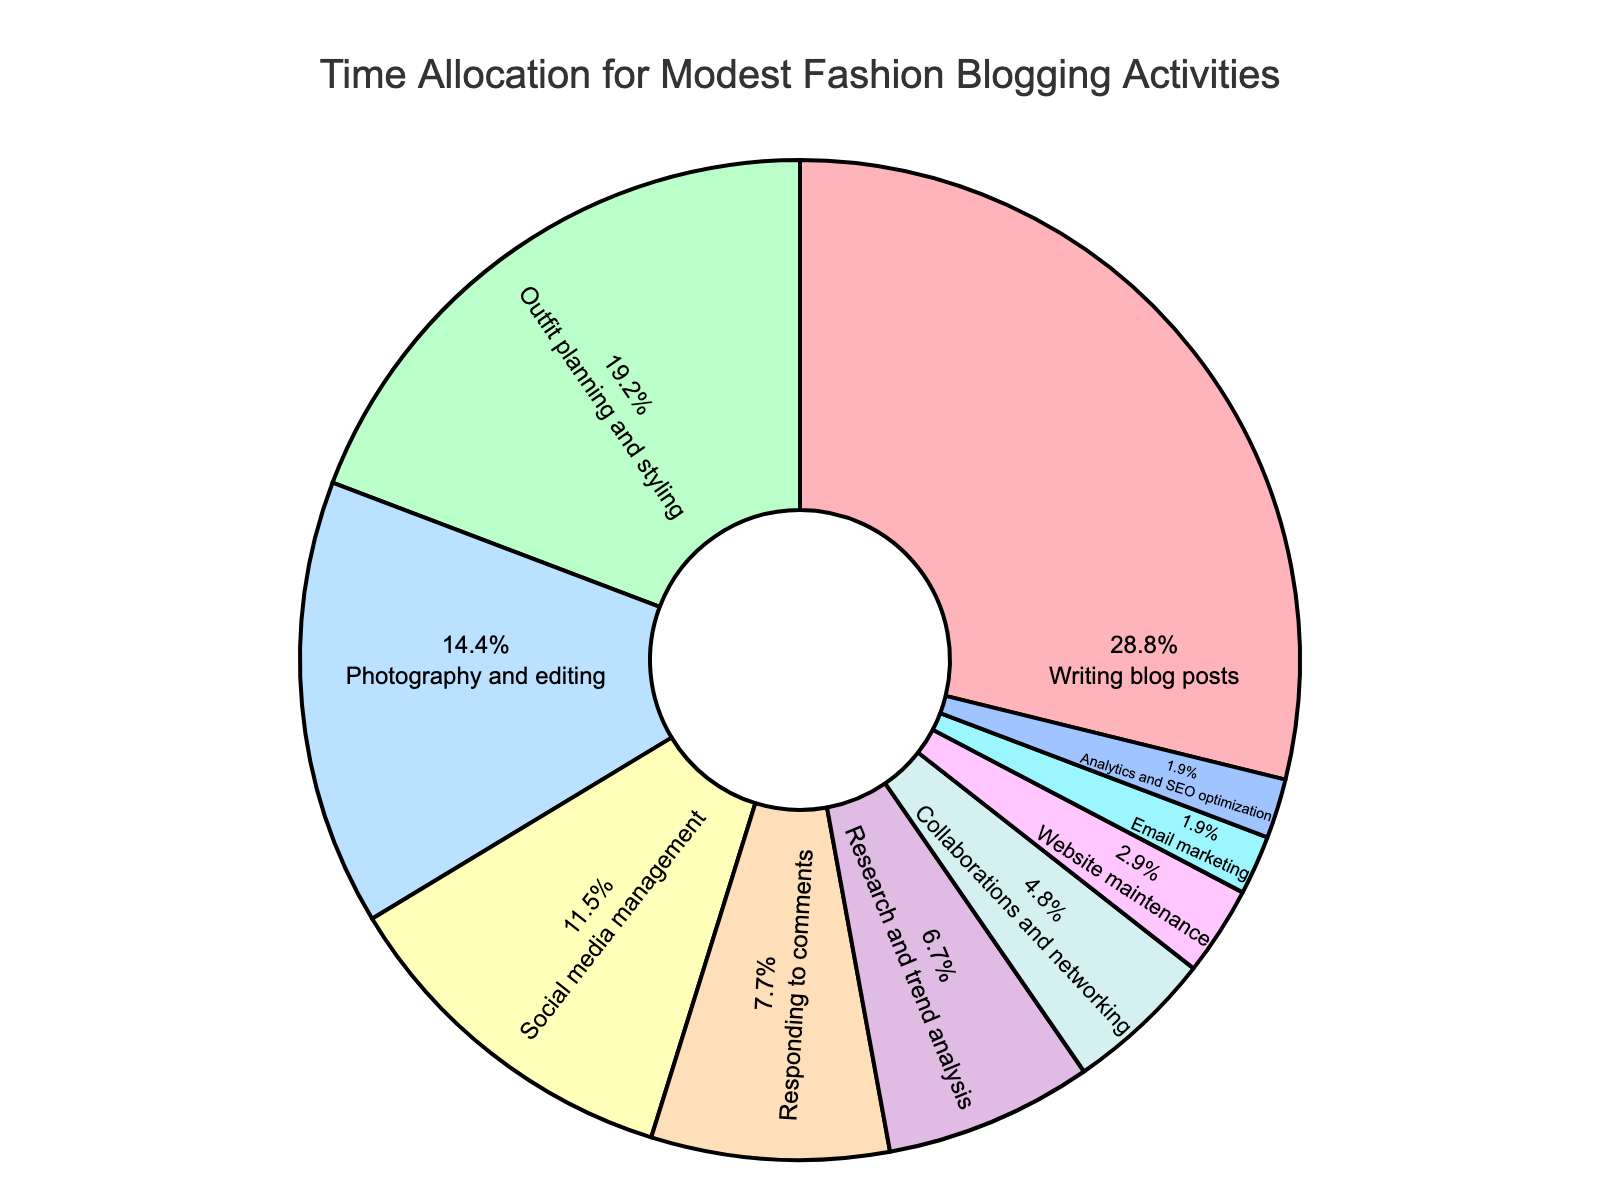What percentage of time is allocated to writing blog posts? The section of the pie chart labeled "Writing blog posts" indicates the percentage of time spent on this activity. Simply read the value displayed on the chart.
Answer: 30% Which activity takes up more time: Social media management or Photography and editing? Locate the sections of the pie chart labeled "Social media management" and "Photography and editing." Compare the displayed percentages: Social media management is 12%, and Photography and editing is 15%.
Answer: Photography and editing What is the combined percentage of time spent on Outfit planning and styling and Research and trend analysis? Locate the pie chart sections for "Outfit planning and styling" which is 20%, and "Research and trend analysis" which is 7%. Add these percentages together: 20% + 7% = 27%.
Answer: 27% Which activity receives the least amount of time allocation, and how much is it? Identify the smallest section of the pie chart. This is labeled "Email marketing" and has the percentage indicated.
Answer: Email marketing, 2% How much more time is allocated to Website maintenance compared to Email marketing? Find the sections for "Website maintenance" and "Email marketing" on the chart. Website maintenance is 3%, and Email marketing is 2%. Subtract the percentage for Email marketing from that of Website maintenance: 3% - 2% = 1%.
Answer: 1% List the top three activities that take the most time. Identify the three largest sections of the pie chart. These are "Writing blog posts" at 30%, "Outfit planning and styling" at 20%, and "Photography and editing" at 15%.
Answer: Writing blog posts, Outfit planning and styling, Photography and editing Compare the time dedicated to Collaborations and networking vs. Research and trend analysis. Which one is more, and by how much? Locate the sections for "Collaborations and networking" and "Research and trend analysis." Collaborations and networking is 5%, and Research and trend analysis is 7%. Subtract the smaller percentage from the larger one: 7% - 5% = 2%.
Answer: Research and trend analysis by 2% What percentage of time is dedicated to activities other than Writing blog posts and Outfit planning and styling? First, find the percentages for "Writing blog posts" (30%) and "Outfit planning and styling" (20%). Subtract the sum of these from 100%: 100% - (30% + 20%) = 50%.
Answer: 50% Which activity has a time allocation closest to 10%? Identify the chart section with a percentage near 10%. "Social media management" is 12%, which is the closest to 10%.
Answer: Social media management 